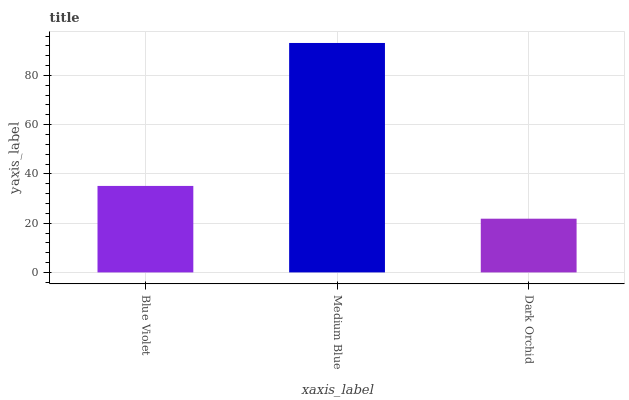Is Dark Orchid the minimum?
Answer yes or no. Yes. Is Medium Blue the maximum?
Answer yes or no. Yes. Is Medium Blue the minimum?
Answer yes or no. No. Is Dark Orchid the maximum?
Answer yes or no. No. Is Medium Blue greater than Dark Orchid?
Answer yes or no. Yes. Is Dark Orchid less than Medium Blue?
Answer yes or no. Yes. Is Dark Orchid greater than Medium Blue?
Answer yes or no. No. Is Medium Blue less than Dark Orchid?
Answer yes or no. No. Is Blue Violet the high median?
Answer yes or no. Yes. Is Blue Violet the low median?
Answer yes or no. Yes. Is Medium Blue the high median?
Answer yes or no. No. Is Dark Orchid the low median?
Answer yes or no. No. 